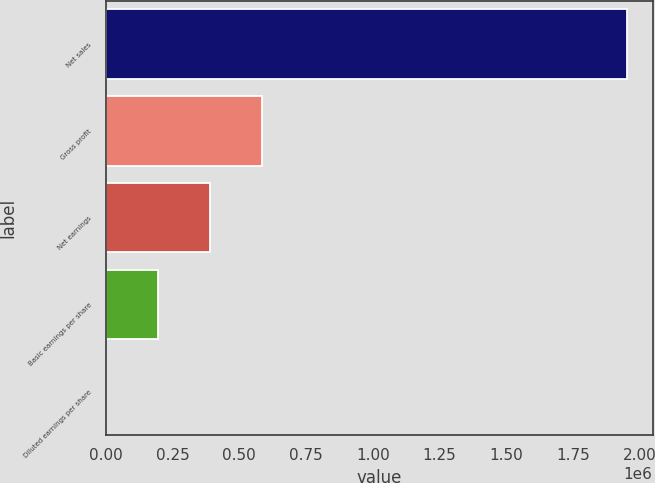<chart> <loc_0><loc_0><loc_500><loc_500><bar_chart><fcel>Net sales<fcel>Gross profit<fcel>Net earnings<fcel>Basic earnings per share<fcel>Diluted earnings per share<nl><fcel>1.95145e+06<fcel>585435<fcel>390291<fcel>195146<fcel>2<nl></chart> 